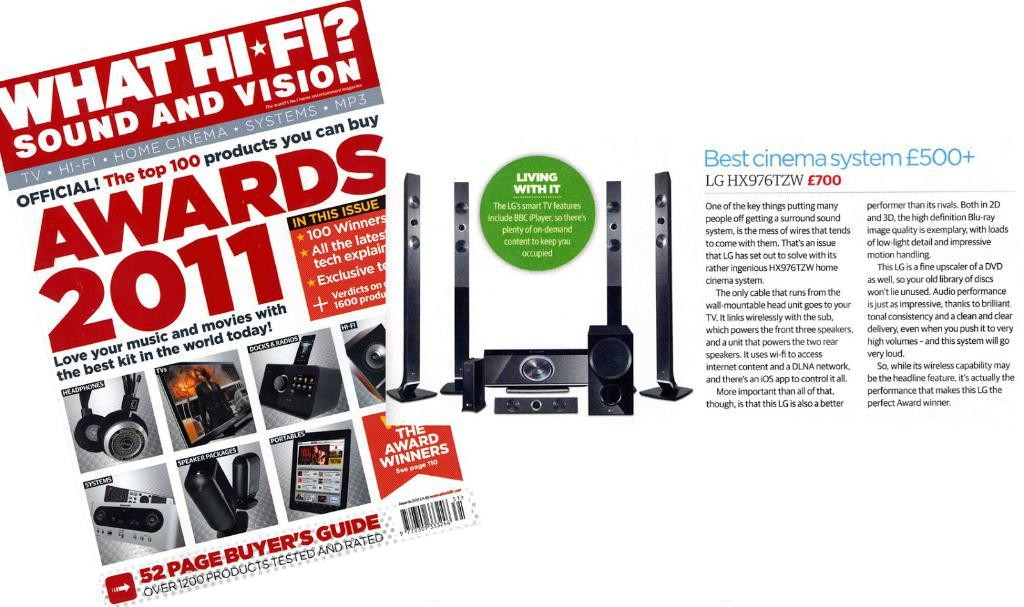<image>
Share a concise interpretation of the image provided. the cover of a magazin called what hi fi sound and vision. 